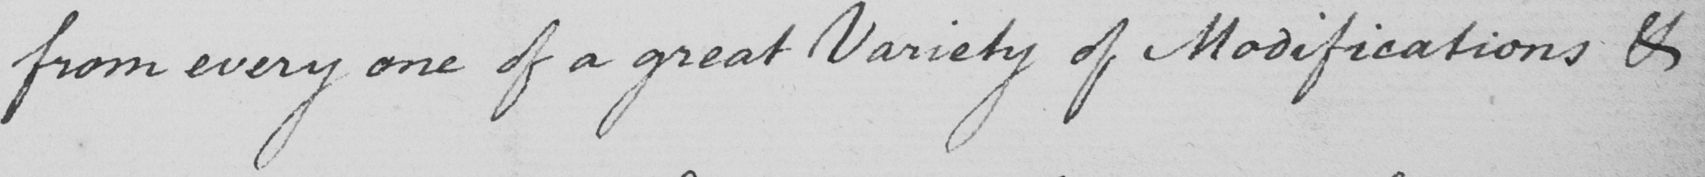Please transcribe the handwritten text in this image. from every one of a great Variety of Modifications & 